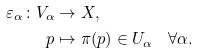Convert formula to latex. <formula><loc_0><loc_0><loc_500><loc_500>\varepsilon _ { \alpha } \colon V _ { \alpha } & \to X , \\ p & \mapsto \pi ( p ) \in U _ { \alpha } \quad \forall \alpha .</formula> 